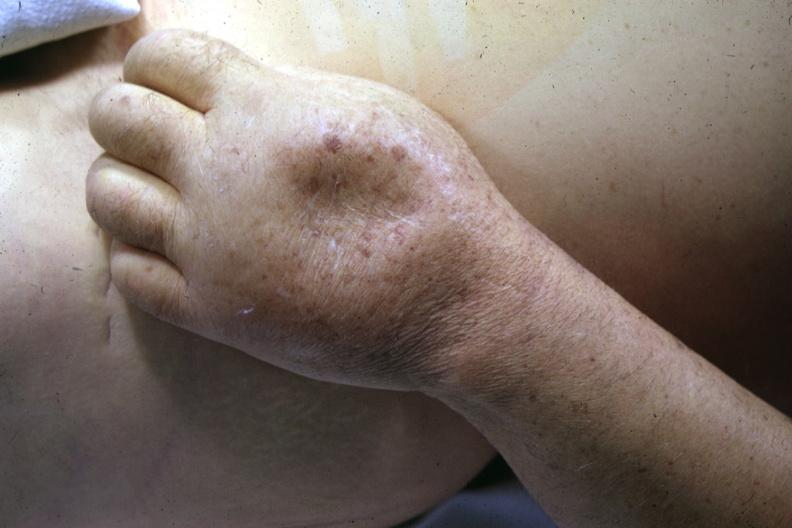does myelomonocytic leukemia show close-up of dorsum of hand with marked pitting edema good example?
Answer the question using a single word or phrase. No 